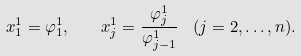Convert formula to latex. <formula><loc_0><loc_0><loc_500><loc_500>x ^ { 1 } _ { 1 } = \varphi ^ { 1 } _ { 1 } , \quad x ^ { 1 } _ { j } = \frac { \varphi ^ { 1 } _ { j } } { \varphi ^ { 1 } _ { j - 1 } } \ \ ( j = 2 , \dots , n ) .</formula> 